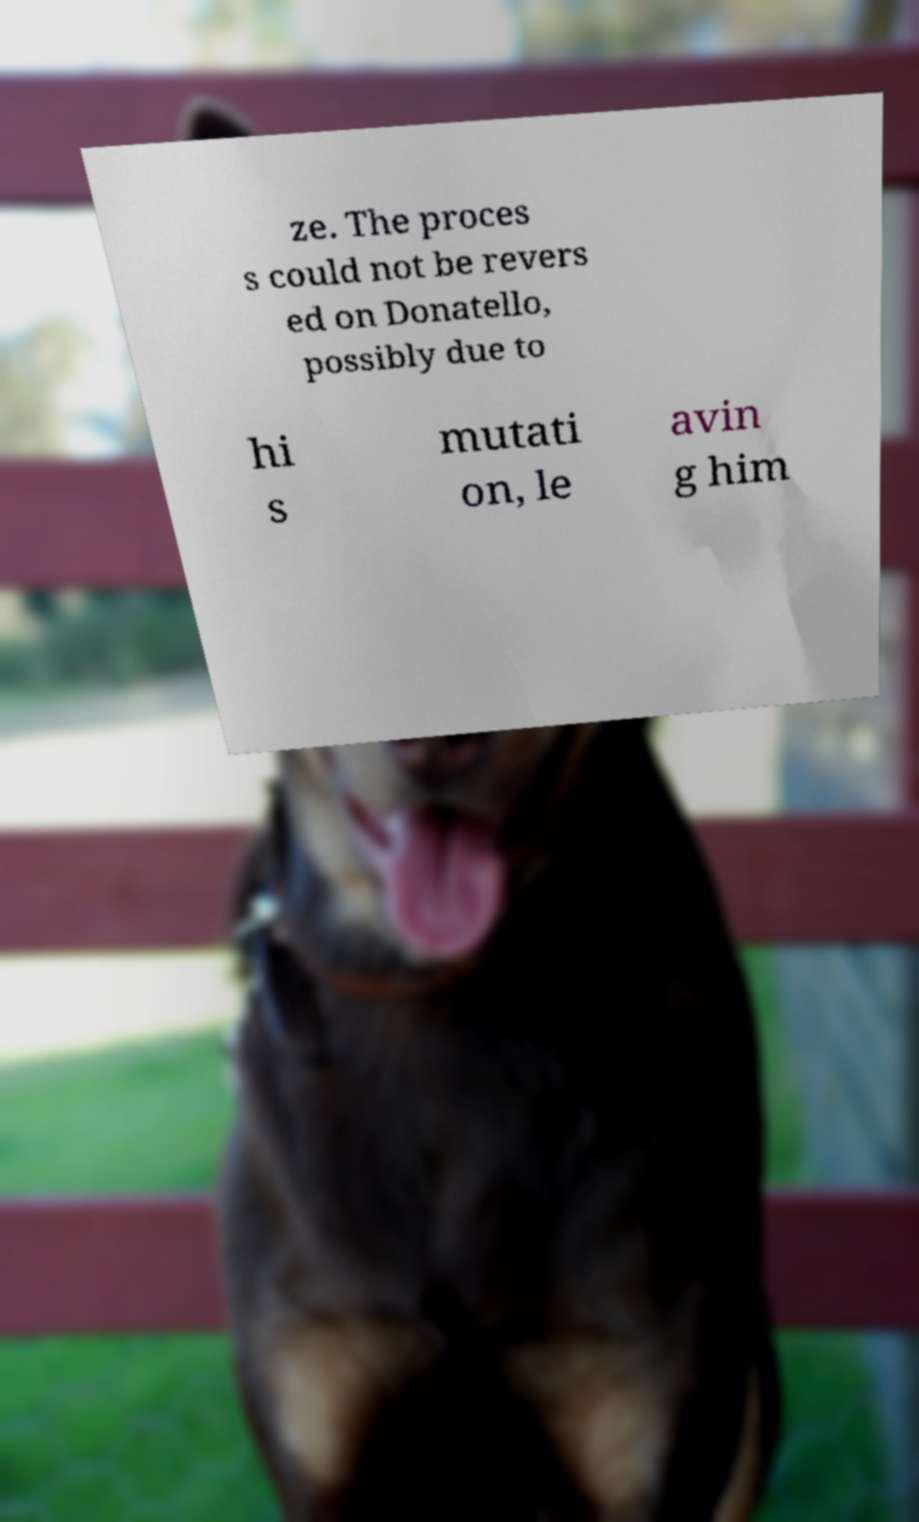Could you extract and type out the text from this image? ze. The proces s could not be revers ed on Donatello, possibly due to hi s mutati on, le avin g him 